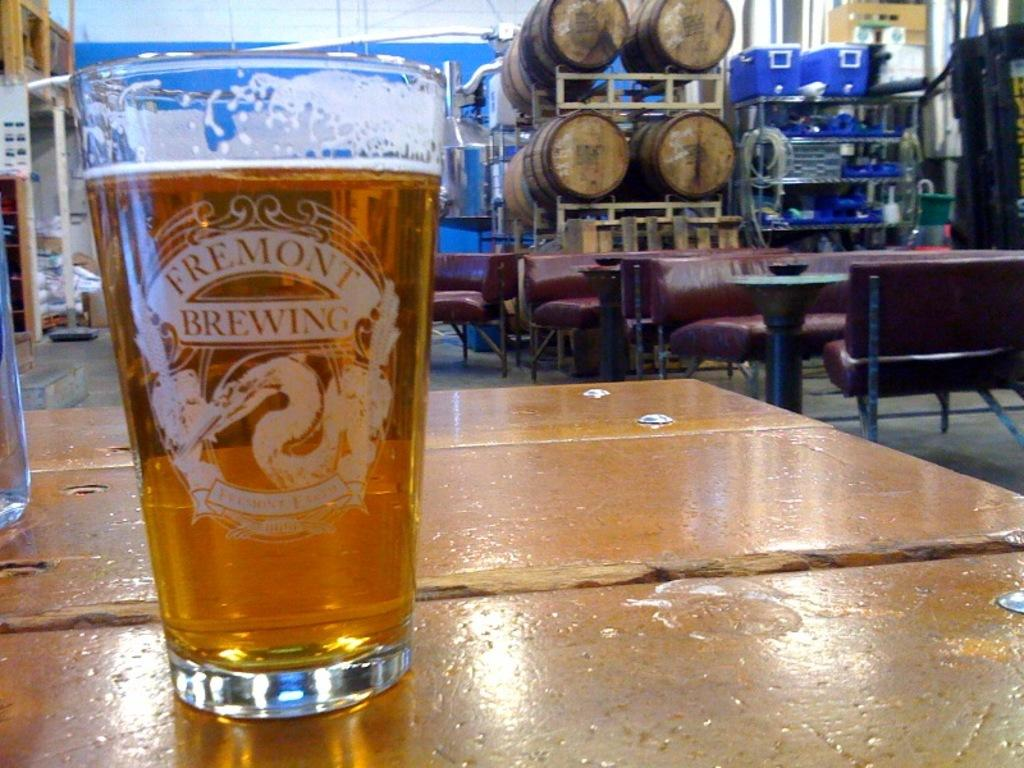What is on the platform in the image? There is a glass with a drink on a platform in the image. What type of furniture can be seen in the image? There are sofas and tables in the image. What else is present in the image besides furniture? There are objects and a rack in the image. What type of surface is visible in the image? The image shows a floor. What month is it in the image? The image does not provide any information about the month; it only shows a glass with a drink, furniture, and other objects. Can you see any toes in the image? There are no toes visible in the image. 